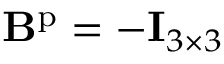Convert formula to latex. <formula><loc_0><loc_0><loc_500><loc_500>B ^ { p } = - I _ { 3 \times 3 }</formula> 